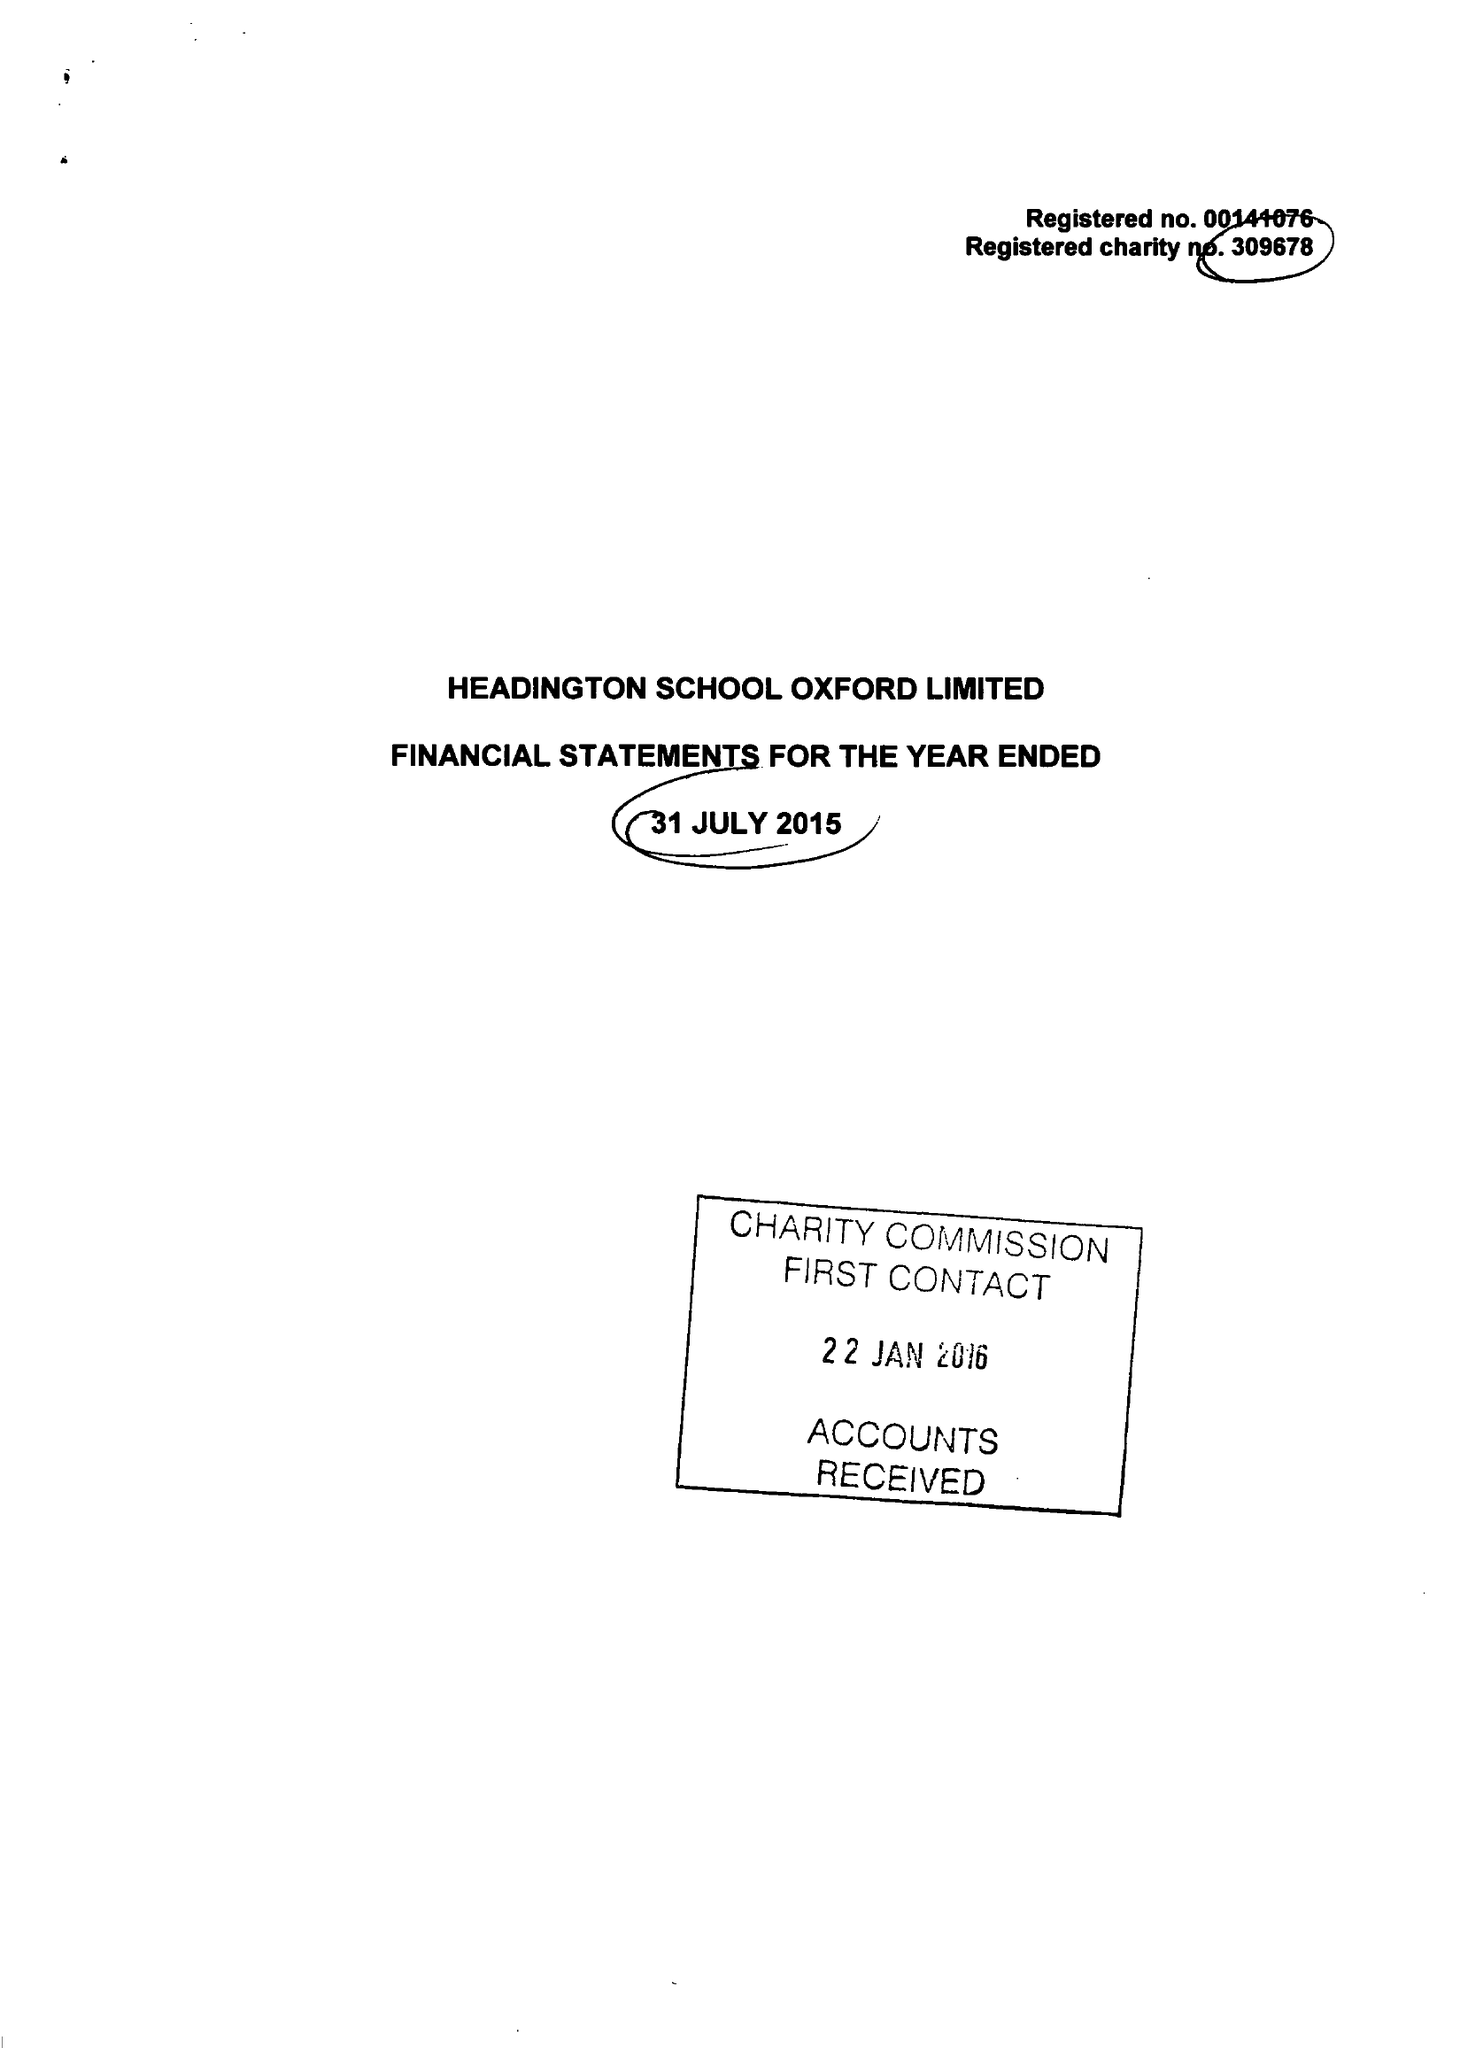What is the value for the address__postcode?
Answer the question using a single word or phrase. OX3 0BL 